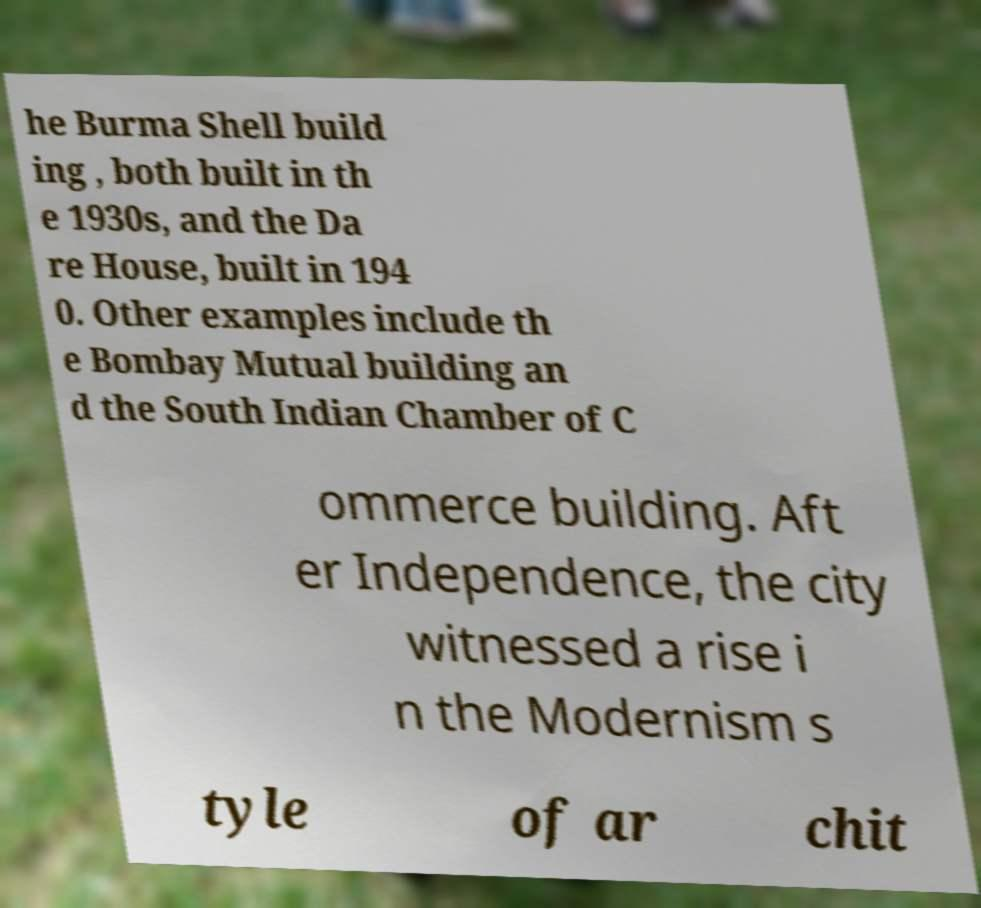What messages or text are displayed in this image? I need them in a readable, typed format. he Burma Shell build ing , both built in th e 1930s, and the Da re House, built in 194 0. Other examples include th e Bombay Mutual building an d the South Indian Chamber of C ommerce building. Aft er Independence, the city witnessed a rise i n the Modernism s tyle of ar chit 